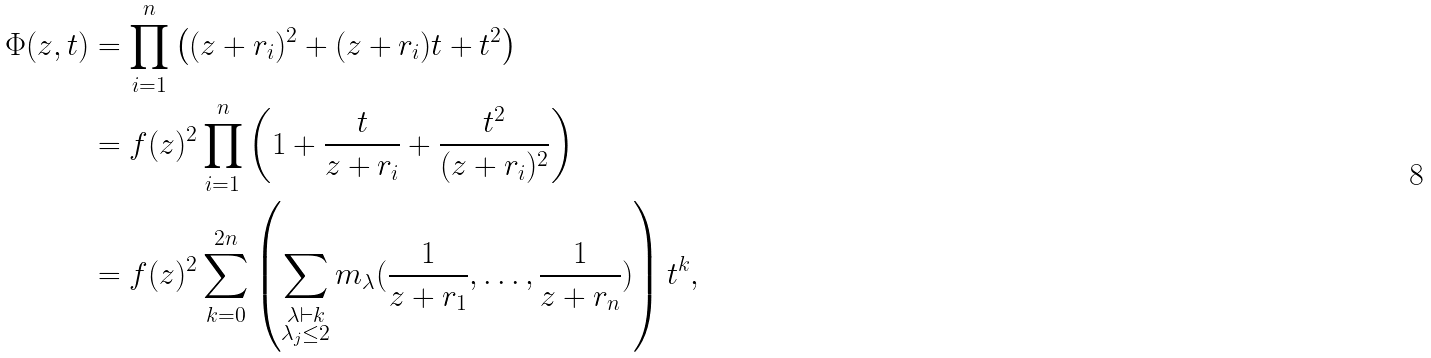<formula> <loc_0><loc_0><loc_500><loc_500>\Phi ( z , t ) & = \prod _ { i = 1 } ^ { n } \left ( ( z + r _ { i } ) ^ { 2 } + ( z + r _ { i } ) t + t ^ { 2 } \right ) \\ & = f ( z ) ^ { 2 } \prod _ { i = 1 } ^ { n } \left ( 1 + \frac { t } { z + r _ { i } } + \frac { t ^ { 2 } } { ( z + r _ { i } ) ^ { 2 } } \right ) \\ & = f ( z ) ^ { 2 } \sum _ { k = 0 } ^ { 2 n } \left ( \sum _ { \substack { \lambda \vdash k \\ \lambda _ { j } \leq 2 } } m _ { \lambda } ( \frac { 1 } { z + r _ { 1 } } , \dots , \frac { 1 } { z + r _ { n } } ) \right ) t ^ { k } ,</formula> 